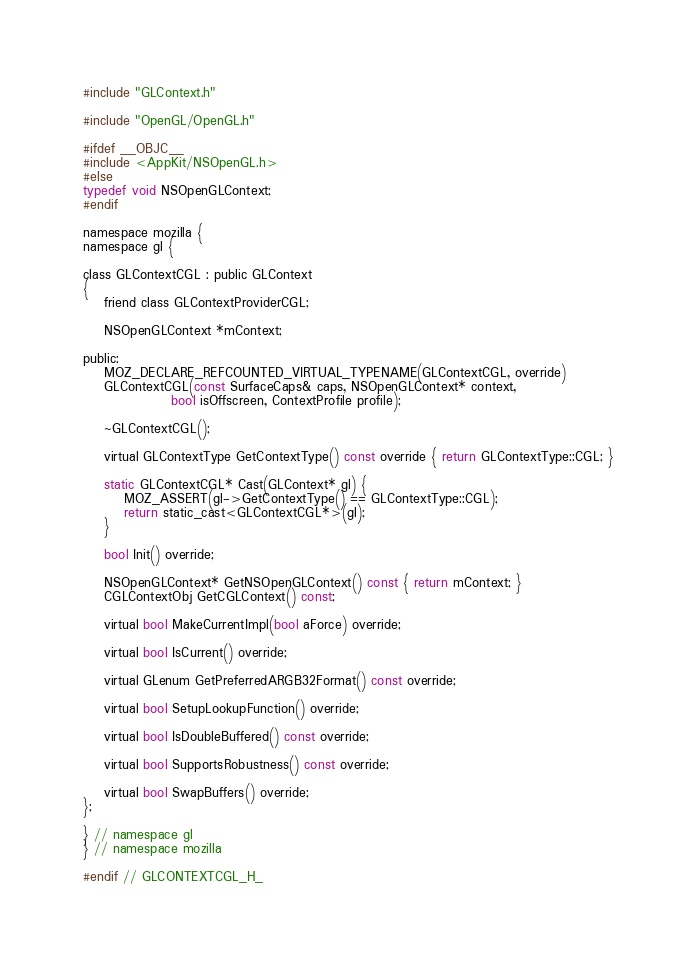Convert code to text. <code><loc_0><loc_0><loc_500><loc_500><_C_>
#include "GLContext.h"

#include "OpenGL/OpenGL.h"

#ifdef __OBJC__
#include <AppKit/NSOpenGL.h>
#else
typedef void NSOpenGLContext;
#endif

namespace mozilla {
namespace gl {

class GLContextCGL : public GLContext
{
    friend class GLContextProviderCGL;

    NSOpenGLContext *mContext;

public:
    MOZ_DECLARE_REFCOUNTED_VIRTUAL_TYPENAME(GLContextCGL, override)
    GLContextCGL(const SurfaceCaps& caps, NSOpenGLContext* context,
                 bool isOffscreen, ContextProfile profile);

    ~GLContextCGL();

    virtual GLContextType GetContextType() const override { return GLContextType::CGL; }

    static GLContextCGL* Cast(GLContext* gl) {
        MOZ_ASSERT(gl->GetContextType() == GLContextType::CGL);
        return static_cast<GLContextCGL*>(gl);
    }

    bool Init() override;

    NSOpenGLContext* GetNSOpenGLContext() const { return mContext; }
    CGLContextObj GetCGLContext() const;

    virtual bool MakeCurrentImpl(bool aForce) override;

    virtual bool IsCurrent() override;

    virtual GLenum GetPreferredARGB32Format() const override;

    virtual bool SetupLookupFunction() override;

    virtual bool IsDoubleBuffered() const override;

    virtual bool SupportsRobustness() const override;

    virtual bool SwapBuffers() override;
};

} // namespace gl
} // namespace mozilla

#endif // GLCONTEXTCGL_H_
</code> 